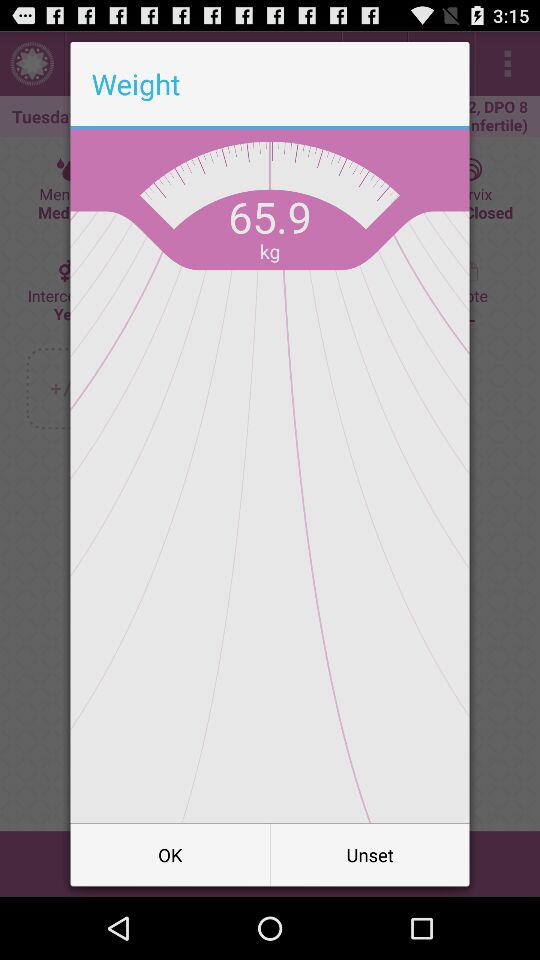How much weight is lost?
When the provided information is insufficient, respond with <no answer>. <no answer> 